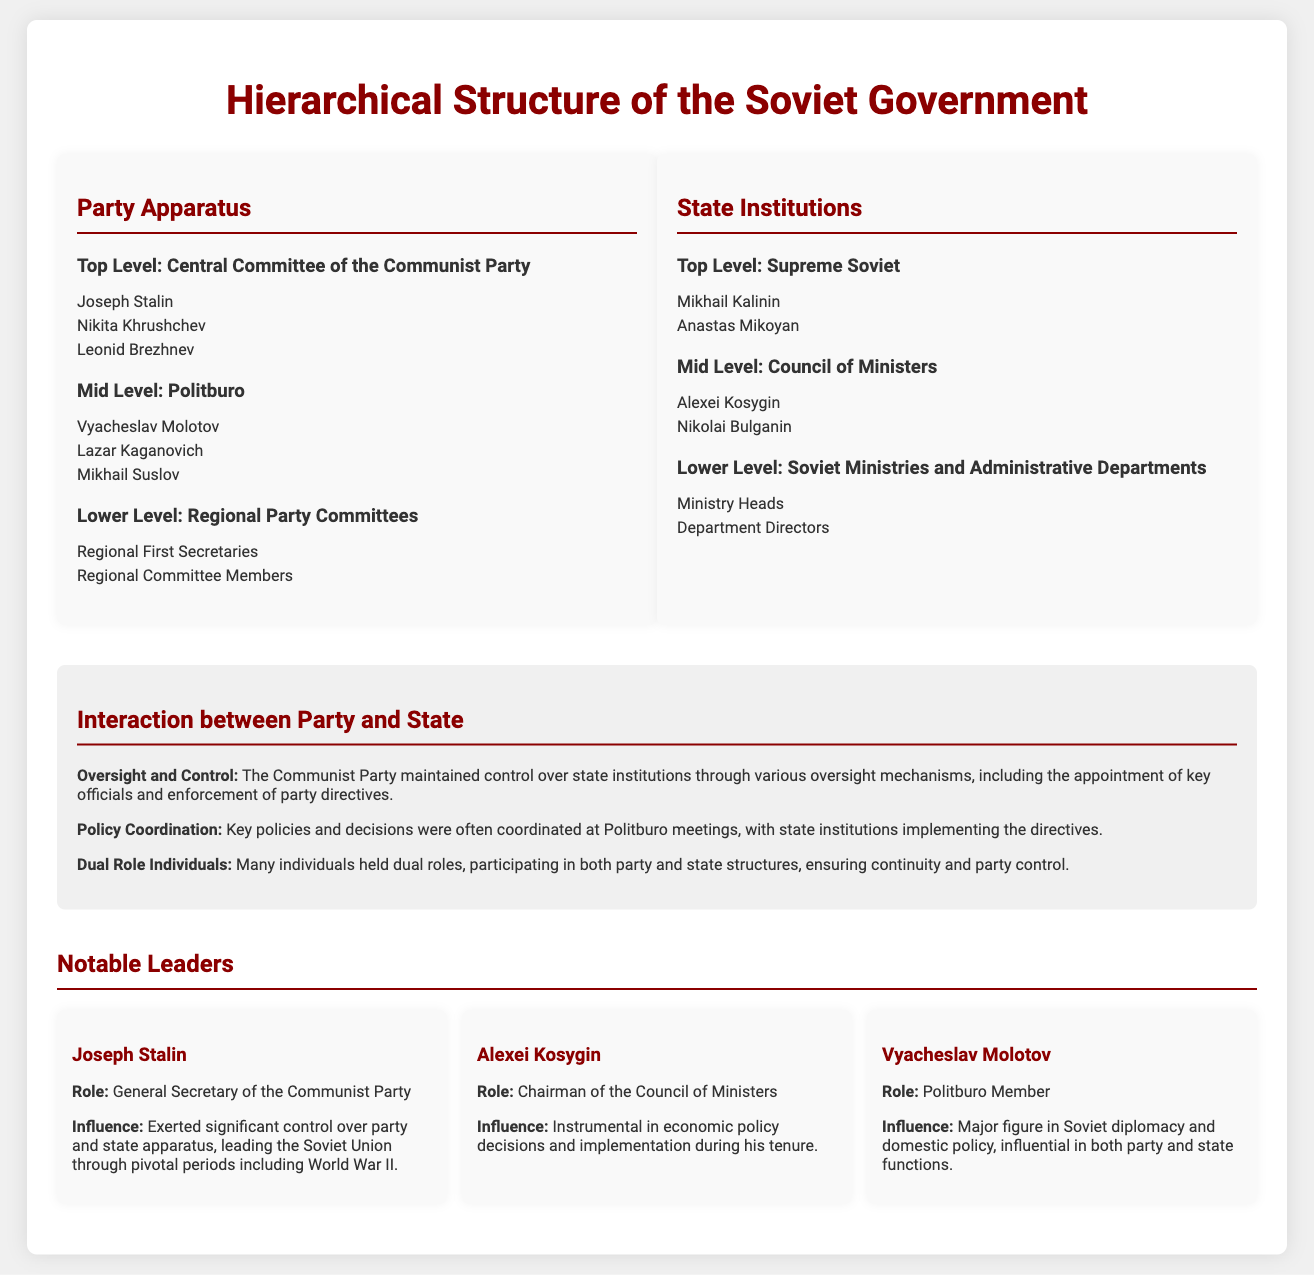What is the highest level in the Party Apparatus? The highest level is the Central Committee of the Communist Party, as indicated in the structure section.
Answer: Central Committee of the Communist Party Who was the Chairman of the Council of Ministers? The document states Alexei Kosygin held the title of Chairman of the Council of Ministers in the State Institutions section.
Answer: Alexei Kosygin Which notable leader influenced Soviet diplomacy? Vyacheslav Molotov is identified as a major figure in Soviet diplomacy within the Notable Leaders section.
Answer: Vyacheslav Molotov How many levels are there in the State Institutions section? The State Institutions section includes three levels: Supreme Soviet, Council of Ministers, and Soviet Ministries and Administrative Departments.
Answer: Three What is the role of the Politburo in the Soviet Government? The Politburo is mentioned as having a mid-level position and is responsible for coordinating key policies and decisions in both Party and State structures.
Answer: Coordination of policies What type of individuals held dual roles in the Soviet Government? The document mentions that individuals holding dual roles participated in both Party and State structures.
Answer: Dual role individuals Which Communist Party leader led during World War II? Joseph Stalin is noted as exerting significant control over the party and state apparatus during pivotal periods, including World War II.
Answer: Joseph Stalin What is one interaction type between the Party and State mentioned in the document? The document lists several interactions, one of which is oversight and control maintained by the Communist Party over state institutions.
Answer: Oversight and Control 